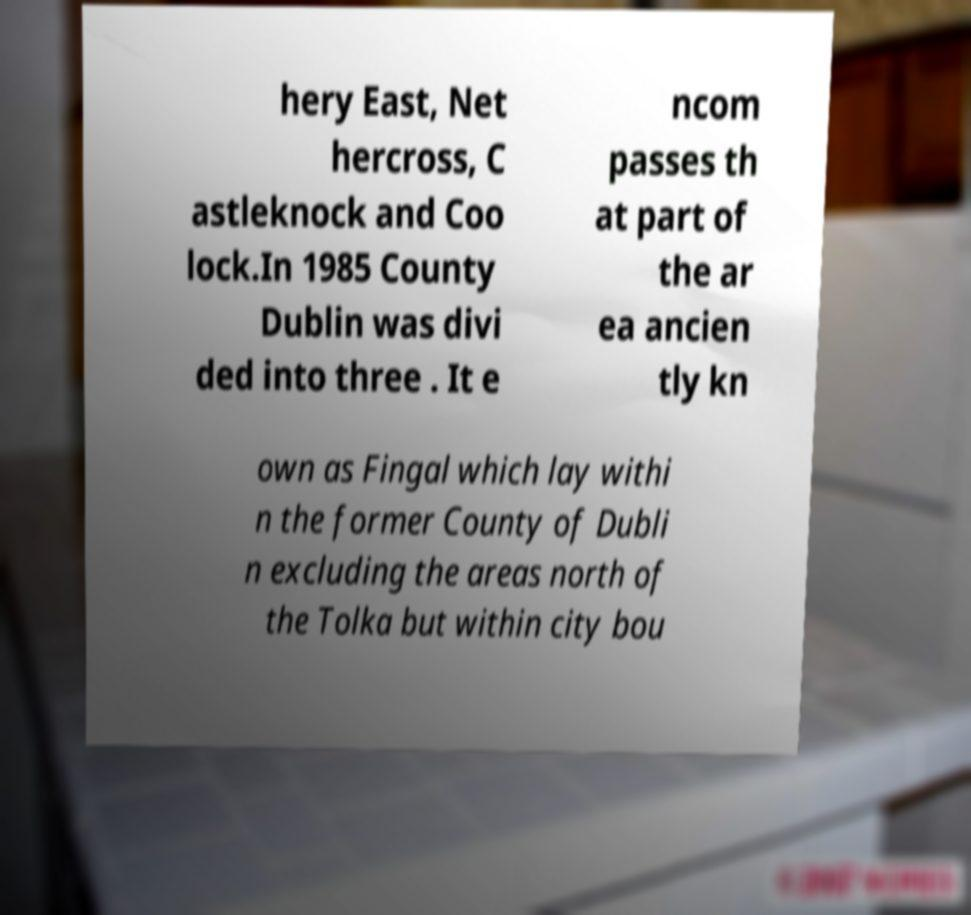Could you assist in decoding the text presented in this image and type it out clearly? hery East, Net hercross, C astleknock and Coo lock.In 1985 County Dublin was divi ded into three . It e ncom passes th at part of the ar ea ancien tly kn own as Fingal which lay withi n the former County of Dubli n excluding the areas north of the Tolka but within city bou 